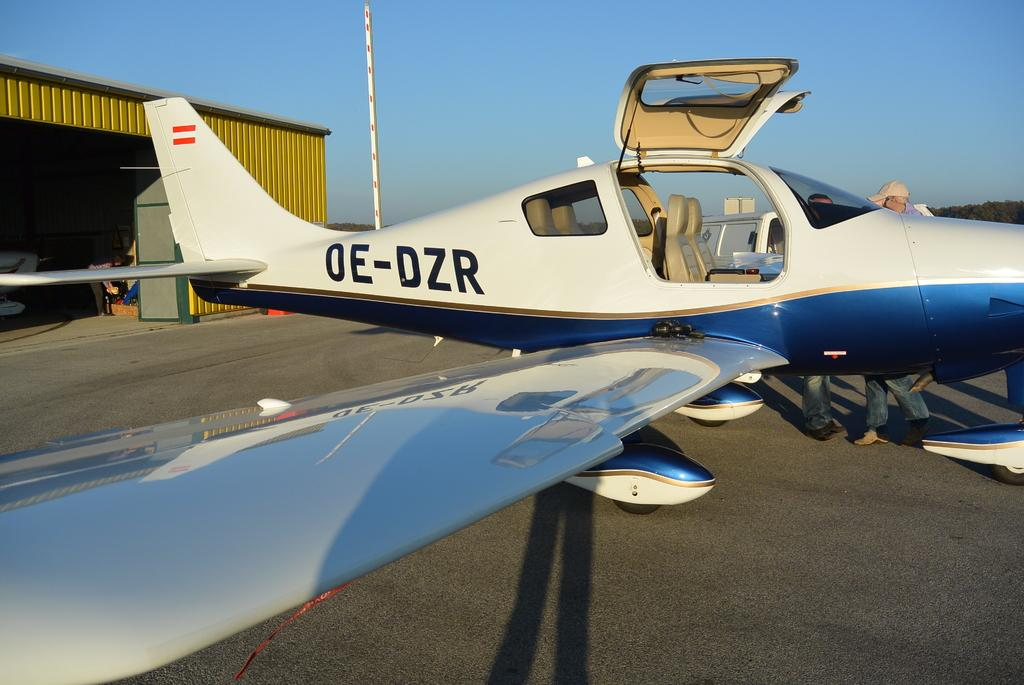<image>
Offer a succinct explanation of the picture presented. A small plane OE-DZR is outside the hangar with its doors opened 